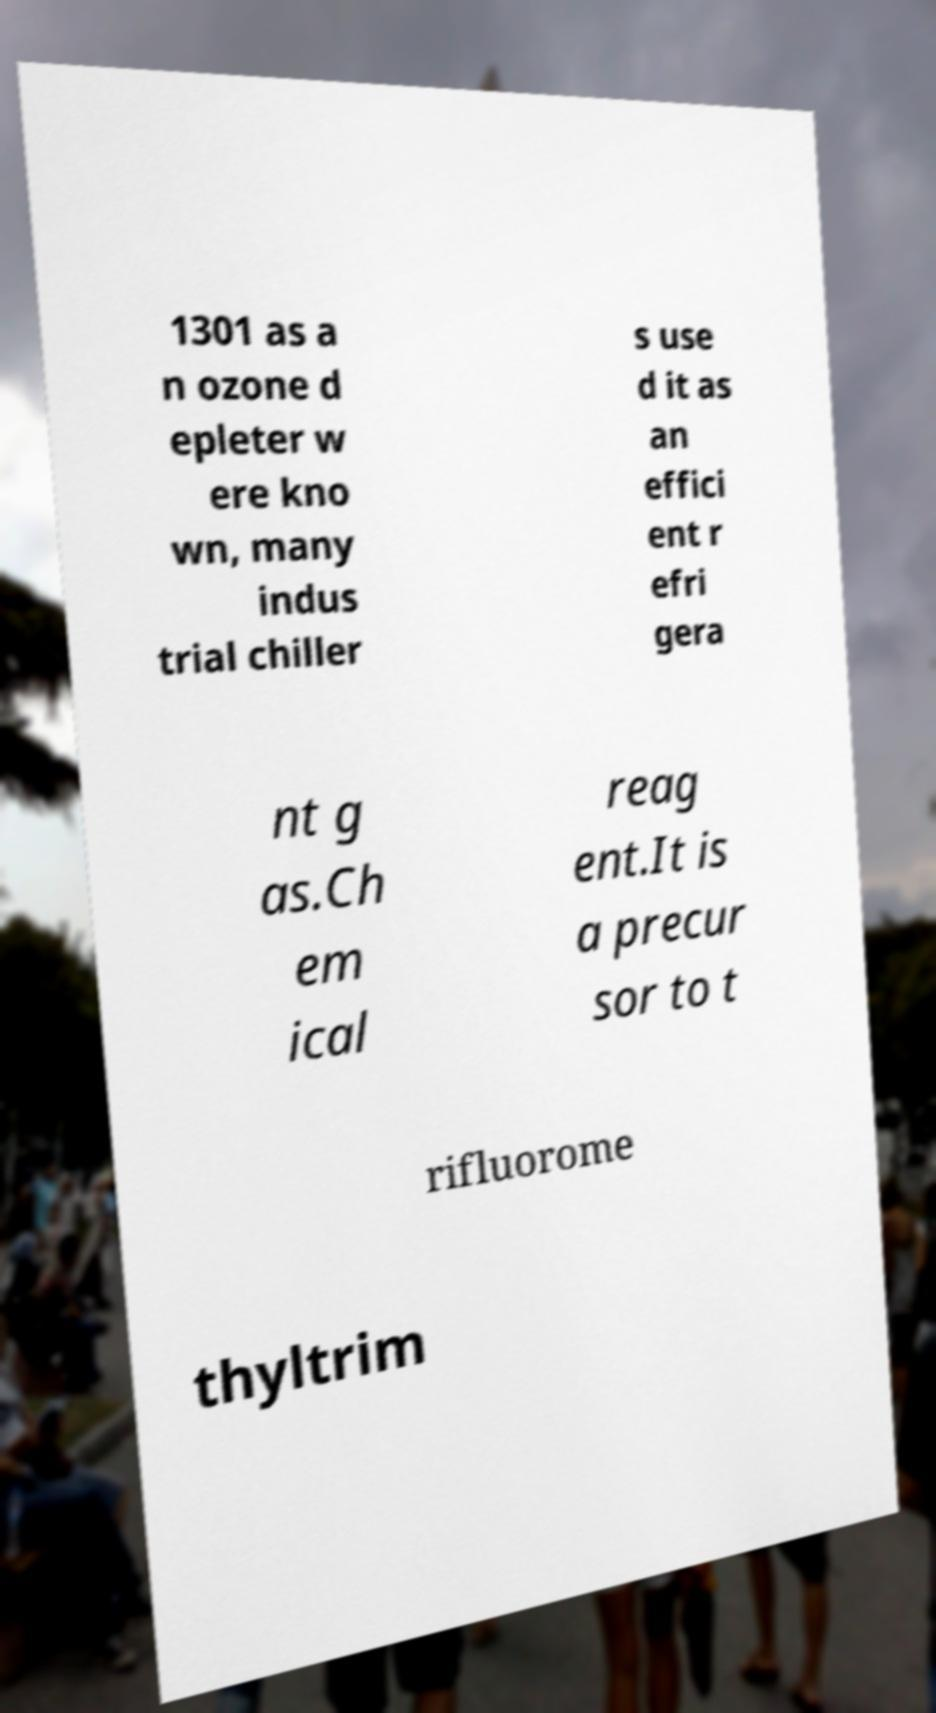Can you accurately transcribe the text from the provided image for me? 1301 as a n ozone d epleter w ere kno wn, many indus trial chiller s use d it as an effici ent r efri gera nt g as.Ch em ical reag ent.It is a precur sor to t rifluorome thyltrim 